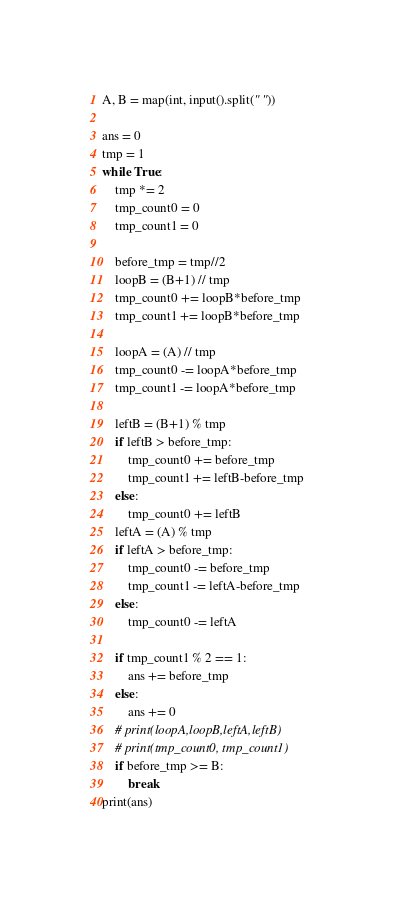<code> <loc_0><loc_0><loc_500><loc_500><_Python_>A, B = map(int, input().split(" "))

ans = 0
tmp = 1
while True:
    tmp *= 2
    tmp_count0 = 0
    tmp_count1 = 0

    before_tmp = tmp//2
    loopB = (B+1) // tmp
    tmp_count0 += loopB*before_tmp
    tmp_count1 += loopB*before_tmp

    loopA = (A) // tmp
    tmp_count0 -= loopA*before_tmp
    tmp_count1 -= loopA*before_tmp

    leftB = (B+1) % tmp
    if leftB > before_tmp:
        tmp_count0 += before_tmp
        tmp_count1 += leftB-before_tmp
    else:
        tmp_count0 += leftB
    leftA = (A) % tmp
    if leftA > before_tmp:
        tmp_count0 -= before_tmp
        tmp_count1 -= leftA-before_tmp
    else:
        tmp_count0 -= leftA

    if tmp_count1 % 2 == 1:
        ans += before_tmp
    else:
        ans += 0
    # print(loopA,loopB,leftA,leftB)
    # print(tmp_count0, tmp_count1)
    if before_tmp >= B:
        break
print(ans)
</code> 